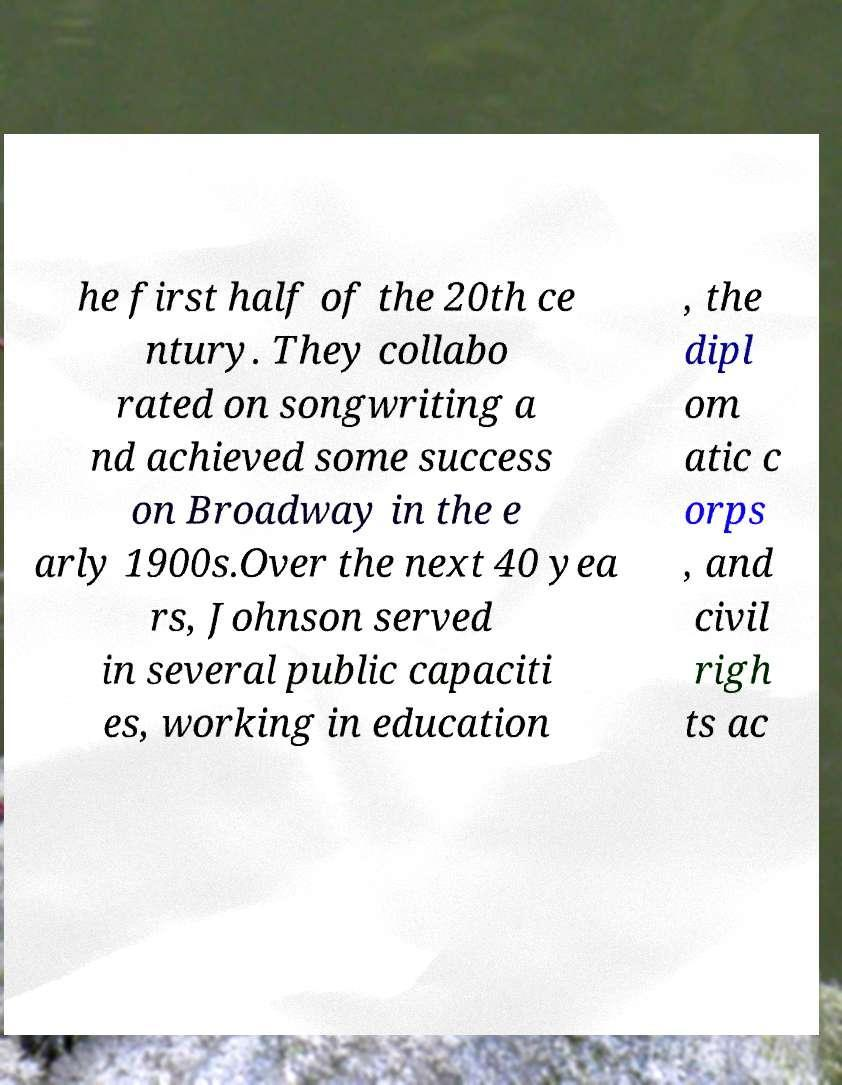Could you extract and type out the text from this image? he first half of the 20th ce ntury. They collabo rated on songwriting a nd achieved some success on Broadway in the e arly 1900s.Over the next 40 yea rs, Johnson served in several public capaciti es, working in education , the dipl om atic c orps , and civil righ ts ac 